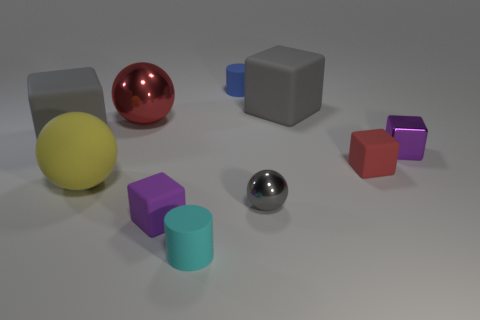Subtract all matte blocks. How many blocks are left? 1 Subtract all spheres. How many objects are left? 7 Subtract all red balls. How many balls are left? 2 Subtract all small rubber cylinders. Subtract all purple rubber cubes. How many objects are left? 7 Add 4 tiny cyan rubber cylinders. How many tiny cyan rubber cylinders are left? 5 Add 7 gray shiny spheres. How many gray shiny spheres exist? 8 Subtract 1 cyan cylinders. How many objects are left? 9 Subtract 3 cubes. How many cubes are left? 2 Subtract all blue cubes. Subtract all yellow cylinders. How many cubes are left? 5 Subtract all brown balls. How many cyan cylinders are left? 1 